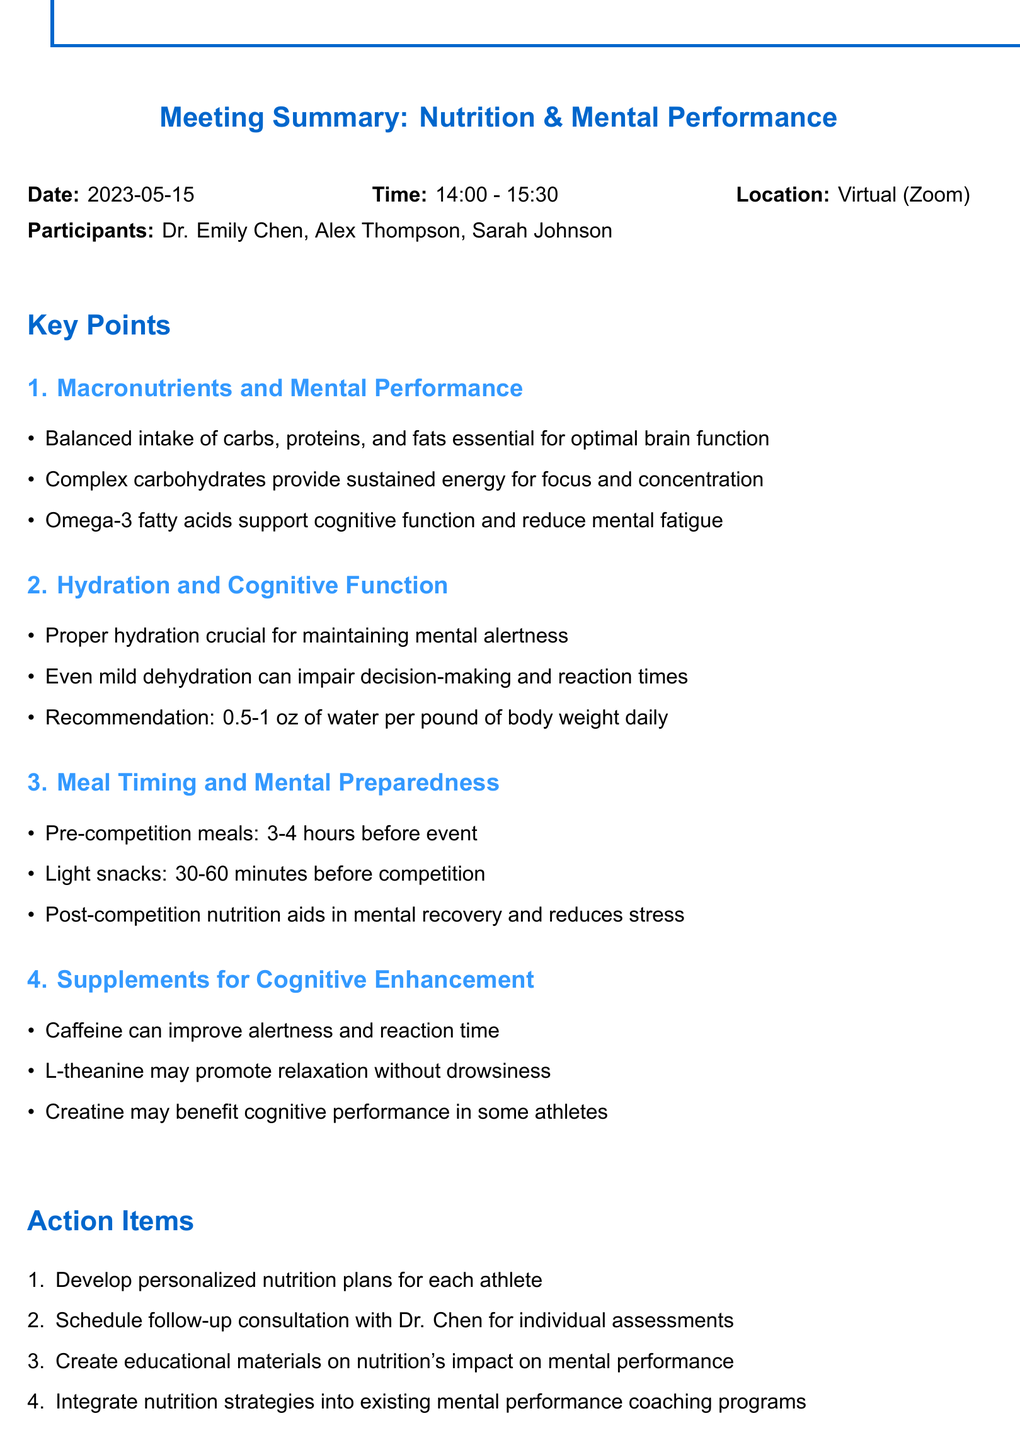What is the date of the meeting? The date of the meeting is specified in the document under meeting details, which is May 15, 2023.
Answer: May 15, 2023 Who are the participants in the meeting? The document lists the participants present during the meeting under the meeting details section.
Answer: Dr. Emily Chen, Alex Thompson, Sarah Johnson What is the recommendation for daily water intake? The recommendation for daily water intake is detailed in the hydration section and specifies the amount needed for athletes.
Answer: 0.5-1 oz of water per pound of body weight How long before the competition should pre-competition meals be consumed? Information on meal timing is outlined in the key points section regarding preparation for competitions.
Answer: 3-4 hours Which supplement may benefit cognitive performance in some athletes? Supplements for cognitive enhancement are discussed, and one is specifically mentioned that may benefit cognitive performance.
Answer: Creatine What is one action item from the meeting? Action items are listed at the end of the document, showing specific follow-up tasks derived from the discussions.
Answer: Develop personalized nutrition plans for each athlete What do complex carbohydrates provide for athletes? The impact of macronutrients is discussed in the key points section, specifying benefits of carbohydrate intake.
Answer: Sustained energy for focus and concentration What effect does mild dehydration have according to the document? The effect of hydration on cognitive function is highlighted, indicating the negative impact on performance.
Answer: Impair decision-making and reaction times 